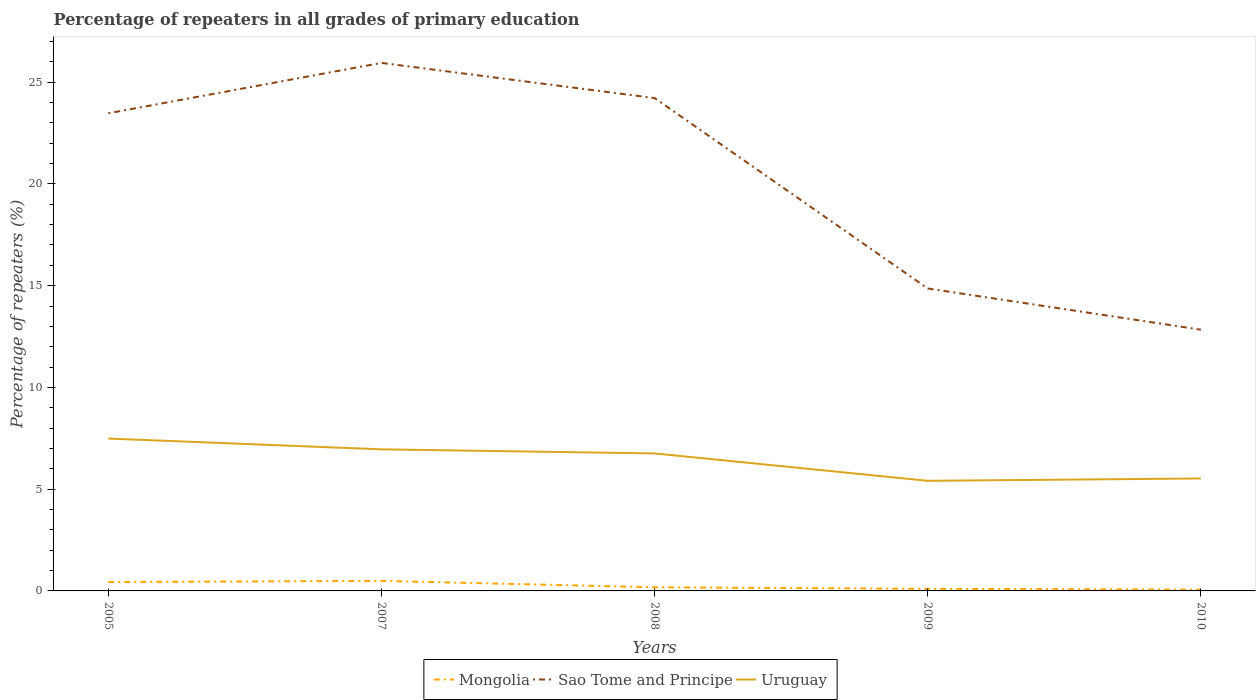Is the number of lines equal to the number of legend labels?
Your response must be concise. Yes. Across all years, what is the maximum percentage of repeaters in Mongolia?
Your answer should be compact. 0.06. In which year was the percentage of repeaters in Mongolia maximum?
Give a very brief answer. 2010. What is the total percentage of repeaters in Uruguay in the graph?
Make the answer very short. 1.55. What is the difference between the highest and the second highest percentage of repeaters in Uruguay?
Make the answer very short. 2.08. What is the difference between the highest and the lowest percentage of repeaters in Uruguay?
Your answer should be compact. 3. Is the percentage of repeaters in Mongolia strictly greater than the percentage of repeaters in Sao Tome and Principe over the years?
Keep it short and to the point. Yes. How many lines are there?
Ensure brevity in your answer.  3. What is the difference between two consecutive major ticks on the Y-axis?
Give a very brief answer. 5. Are the values on the major ticks of Y-axis written in scientific E-notation?
Your answer should be compact. No. Does the graph contain any zero values?
Give a very brief answer. No. How many legend labels are there?
Make the answer very short. 3. How are the legend labels stacked?
Ensure brevity in your answer.  Horizontal. What is the title of the graph?
Ensure brevity in your answer.  Percentage of repeaters in all grades of primary education. Does "Equatorial Guinea" appear as one of the legend labels in the graph?
Provide a short and direct response. No. What is the label or title of the X-axis?
Offer a very short reply. Years. What is the label or title of the Y-axis?
Your answer should be very brief. Percentage of repeaters (%). What is the Percentage of repeaters (%) of Mongolia in 2005?
Keep it short and to the point. 0.44. What is the Percentage of repeaters (%) in Sao Tome and Principe in 2005?
Provide a succinct answer. 23.47. What is the Percentage of repeaters (%) of Uruguay in 2005?
Your answer should be very brief. 7.49. What is the Percentage of repeaters (%) in Mongolia in 2007?
Your response must be concise. 0.49. What is the Percentage of repeaters (%) in Sao Tome and Principe in 2007?
Your answer should be compact. 25.95. What is the Percentage of repeaters (%) in Uruguay in 2007?
Make the answer very short. 6.96. What is the Percentage of repeaters (%) in Mongolia in 2008?
Offer a very short reply. 0.18. What is the Percentage of repeaters (%) of Sao Tome and Principe in 2008?
Keep it short and to the point. 24.22. What is the Percentage of repeaters (%) of Uruguay in 2008?
Offer a very short reply. 6.76. What is the Percentage of repeaters (%) of Mongolia in 2009?
Your response must be concise. 0.1. What is the Percentage of repeaters (%) of Sao Tome and Principe in 2009?
Ensure brevity in your answer.  14.86. What is the Percentage of repeaters (%) in Uruguay in 2009?
Provide a short and direct response. 5.41. What is the Percentage of repeaters (%) in Mongolia in 2010?
Provide a succinct answer. 0.06. What is the Percentage of repeaters (%) in Sao Tome and Principe in 2010?
Your answer should be compact. 12.84. What is the Percentage of repeaters (%) in Uruguay in 2010?
Provide a short and direct response. 5.53. Across all years, what is the maximum Percentage of repeaters (%) of Mongolia?
Make the answer very short. 0.49. Across all years, what is the maximum Percentage of repeaters (%) of Sao Tome and Principe?
Keep it short and to the point. 25.95. Across all years, what is the maximum Percentage of repeaters (%) of Uruguay?
Ensure brevity in your answer.  7.49. Across all years, what is the minimum Percentage of repeaters (%) of Mongolia?
Make the answer very short. 0.06. Across all years, what is the minimum Percentage of repeaters (%) of Sao Tome and Principe?
Offer a terse response. 12.84. Across all years, what is the minimum Percentage of repeaters (%) in Uruguay?
Your answer should be very brief. 5.41. What is the total Percentage of repeaters (%) in Mongolia in the graph?
Give a very brief answer. 1.28. What is the total Percentage of repeaters (%) in Sao Tome and Principe in the graph?
Offer a terse response. 101.34. What is the total Percentage of repeaters (%) of Uruguay in the graph?
Your answer should be compact. 32.14. What is the difference between the Percentage of repeaters (%) of Mongolia in 2005 and that in 2007?
Give a very brief answer. -0.06. What is the difference between the Percentage of repeaters (%) of Sao Tome and Principe in 2005 and that in 2007?
Your answer should be very brief. -2.47. What is the difference between the Percentage of repeaters (%) in Uruguay in 2005 and that in 2007?
Provide a short and direct response. 0.53. What is the difference between the Percentage of repeaters (%) in Mongolia in 2005 and that in 2008?
Your answer should be compact. 0.26. What is the difference between the Percentage of repeaters (%) in Sao Tome and Principe in 2005 and that in 2008?
Provide a succinct answer. -0.75. What is the difference between the Percentage of repeaters (%) of Uruguay in 2005 and that in 2008?
Your answer should be compact. 0.73. What is the difference between the Percentage of repeaters (%) in Mongolia in 2005 and that in 2009?
Make the answer very short. 0.33. What is the difference between the Percentage of repeaters (%) in Sao Tome and Principe in 2005 and that in 2009?
Make the answer very short. 8.61. What is the difference between the Percentage of repeaters (%) of Uruguay in 2005 and that in 2009?
Offer a terse response. 2.08. What is the difference between the Percentage of repeaters (%) in Mongolia in 2005 and that in 2010?
Provide a short and direct response. 0.37. What is the difference between the Percentage of repeaters (%) of Sao Tome and Principe in 2005 and that in 2010?
Give a very brief answer. 10.64. What is the difference between the Percentage of repeaters (%) in Uruguay in 2005 and that in 2010?
Provide a short and direct response. 1.96. What is the difference between the Percentage of repeaters (%) in Mongolia in 2007 and that in 2008?
Provide a succinct answer. 0.31. What is the difference between the Percentage of repeaters (%) of Sao Tome and Principe in 2007 and that in 2008?
Your answer should be very brief. 1.73. What is the difference between the Percentage of repeaters (%) in Uruguay in 2007 and that in 2008?
Your answer should be compact. 0.2. What is the difference between the Percentage of repeaters (%) of Mongolia in 2007 and that in 2009?
Your response must be concise. 0.39. What is the difference between the Percentage of repeaters (%) in Sao Tome and Principe in 2007 and that in 2009?
Your answer should be compact. 11.09. What is the difference between the Percentage of repeaters (%) in Uruguay in 2007 and that in 2009?
Give a very brief answer. 1.55. What is the difference between the Percentage of repeaters (%) of Mongolia in 2007 and that in 2010?
Your answer should be very brief. 0.43. What is the difference between the Percentage of repeaters (%) in Sao Tome and Principe in 2007 and that in 2010?
Your response must be concise. 13.11. What is the difference between the Percentage of repeaters (%) in Uruguay in 2007 and that in 2010?
Your answer should be very brief. 1.43. What is the difference between the Percentage of repeaters (%) of Mongolia in 2008 and that in 2009?
Your answer should be compact. 0.08. What is the difference between the Percentage of repeaters (%) of Sao Tome and Principe in 2008 and that in 2009?
Offer a very short reply. 9.36. What is the difference between the Percentage of repeaters (%) in Uruguay in 2008 and that in 2009?
Offer a terse response. 1.35. What is the difference between the Percentage of repeaters (%) of Mongolia in 2008 and that in 2010?
Offer a very short reply. 0.12. What is the difference between the Percentage of repeaters (%) of Sao Tome and Principe in 2008 and that in 2010?
Give a very brief answer. 11.38. What is the difference between the Percentage of repeaters (%) in Uruguay in 2008 and that in 2010?
Keep it short and to the point. 1.23. What is the difference between the Percentage of repeaters (%) in Mongolia in 2009 and that in 2010?
Give a very brief answer. 0.04. What is the difference between the Percentage of repeaters (%) in Sao Tome and Principe in 2009 and that in 2010?
Your response must be concise. 2.02. What is the difference between the Percentage of repeaters (%) in Uruguay in 2009 and that in 2010?
Your answer should be very brief. -0.12. What is the difference between the Percentage of repeaters (%) of Mongolia in 2005 and the Percentage of repeaters (%) of Sao Tome and Principe in 2007?
Provide a short and direct response. -25.51. What is the difference between the Percentage of repeaters (%) in Mongolia in 2005 and the Percentage of repeaters (%) in Uruguay in 2007?
Offer a terse response. -6.52. What is the difference between the Percentage of repeaters (%) of Sao Tome and Principe in 2005 and the Percentage of repeaters (%) of Uruguay in 2007?
Keep it short and to the point. 16.52. What is the difference between the Percentage of repeaters (%) of Mongolia in 2005 and the Percentage of repeaters (%) of Sao Tome and Principe in 2008?
Offer a terse response. -23.78. What is the difference between the Percentage of repeaters (%) of Mongolia in 2005 and the Percentage of repeaters (%) of Uruguay in 2008?
Provide a short and direct response. -6.32. What is the difference between the Percentage of repeaters (%) in Sao Tome and Principe in 2005 and the Percentage of repeaters (%) in Uruguay in 2008?
Your answer should be very brief. 16.72. What is the difference between the Percentage of repeaters (%) of Mongolia in 2005 and the Percentage of repeaters (%) of Sao Tome and Principe in 2009?
Keep it short and to the point. -14.43. What is the difference between the Percentage of repeaters (%) of Mongolia in 2005 and the Percentage of repeaters (%) of Uruguay in 2009?
Offer a very short reply. -4.98. What is the difference between the Percentage of repeaters (%) in Sao Tome and Principe in 2005 and the Percentage of repeaters (%) in Uruguay in 2009?
Provide a succinct answer. 18.06. What is the difference between the Percentage of repeaters (%) in Mongolia in 2005 and the Percentage of repeaters (%) in Sao Tome and Principe in 2010?
Provide a short and direct response. -12.4. What is the difference between the Percentage of repeaters (%) of Mongolia in 2005 and the Percentage of repeaters (%) of Uruguay in 2010?
Provide a short and direct response. -5.09. What is the difference between the Percentage of repeaters (%) of Sao Tome and Principe in 2005 and the Percentage of repeaters (%) of Uruguay in 2010?
Provide a succinct answer. 17.95. What is the difference between the Percentage of repeaters (%) of Mongolia in 2007 and the Percentage of repeaters (%) of Sao Tome and Principe in 2008?
Offer a very short reply. -23.73. What is the difference between the Percentage of repeaters (%) of Mongolia in 2007 and the Percentage of repeaters (%) of Uruguay in 2008?
Offer a very short reply. -6.26. What is the difference between the Percentage of repeaters (%) of Sao Tome and Principe in 2007 and the Percentage of repeaters (%) of Uruguay in 2008?
Your response must be concise. 19.19. What is the difference between the Percentage of repeaters (%) of Mongolia in 2007 and the Percentage of repeaters (%) of Sao Tome and Principe in 2009?
Your answer should be compact. -14.37. What is the difference between the Percentage of repeaters (%) in Mongolia in 2007 and the Percentage of repeaters (%) in Uruguay in 2009?
Provide a succinct answer. -4.92. What is the difference between the Percentage of repeaters (%) of Sao Tome and Principe in 2007 and the Percentage of repeaters (%) of Uruguay in 2009?
Provide a succinct answer. 20.54. What is the difference between the Percentage of repeaters (%) of Mongolia in 2007 and the Percentage of repeaters (%) of Sao Tome and Principe in 2010?
Offer a very short reply. -12.34. What is the difference between the Percentage of repeaters (%) in Mongolia in 2007 and the Percentage of repeaters (%) in Uruguay in 2010?
Ensure brevity in your answer.  -5.03. What is the difference between the Percentage of repeaters (%) of Sao Tome and Principe in 2007 and the Percentage of repeaters (%) of Uruguay in 2010?
Make the answer very short. 20.42. What is the difference between the Percentage of repeaters (%) of Mongolia in 2008 and the Percentage of repeaters (%) of Sao Tome and Principe in 2009?
Provide a succinct answer. -14.68. What is the difference between the Percentage of repeaters (%) in Mongolia in 2008 and the Percentage of repeaters (%) in Uruguay in 2009?
Offer a terse response. -5.23. What is the difference between the Percentage of repeaters (%) of Sao Tome and Principe in 2008 and the Percentage of repeaters (%) of Uruguay in 2009?
Ensure brevity in your answer.  18.81. What is the difference between the Percentage of repeaters (%) of Mongolia in 2008 and the Percentage of repeaters (%) of Sao Tome and Principe in 2010?
Provide a short and direct response. -12.66. What is the difference between the Percentage of repeaters (%) in Mongolia in 2008 and the Percentage of repeaters (%) in Uruguay in 2010?
Make the answer very short. -5.35. What is the difference between the Percentage of repeaters (%) of Sao Tome and Principe in 2008 and the Percentage of repeaters (%) of Uruguay in 2010?
Give a very brief answer. 18.69. What is the difference between the Percentage of repeaters (%) of Mongolia in 2009 and the Percentage of repeaters (%) of Sao Tome and Principe in 2010?
Ensure brevity in your answer.  -12.74. What is the difference between the Percentage of repeaters (%) in Mongolia in 2009 and the Percentage of repeaters (%) in Uruguay in 2010?
Your answer should be compact. -5.43. What is the difference between the Percentage of repeaters (%) of Sao Tome and Principe in 2009 and the Percentage of repeaters (%) of Uruguay in 2010?
Make the answer very short. 9.34. What is the average Percentage of repeaters (%) in Mongolia per year?
Offer a terse response. 0.26. What is the average Percentage of repeaters (%) of Sao Tome and Principe per year?
Give a very brief answer. 20.27. What is the average Percentage of repeaters (%) of Uruguay per year?
Give a very brief answer. 6.43. In the year 2005, what is the difference between the Percentage of repeaters (%) in Mongolia and Percentage of repeaters (%) in Sao Tome and Principe?
Give a very brief answer. -23.04. In the year 2005, what is the difference between the Percentage of repeaters (%) in Mongolia and Percentage of repeaters (%) in Uruguay?
Provide a short and direct response. -7.05. In the year 2005, what is the difference between the Percentage of repeaters (%) of Sao Tome and Principe and Percentage of repeaters (%) of Uruguay?
Ensure brevity in your answer.  15.99. In the year 2007, what is the difference between the Percentage of repeaters (%) of Mongolia and Percentage of repeaters (%) of Sao Tome and Principe?
Offer a very short reply. -25.45. In the year 2007, what is the difference between the Percentage of repeaters (%) in Mongolia and Percentage of repeaters (%) in Uruguay?
Offer a very short reply. -6.46. In the year 2007, what is the difference between the Percentage of repeaters (%) in Sao Tome and Principe and Percentage of repeaters (%) in Uruguay?
Offer a terse response. 18.99. In the year 2008, what is the difference between the Percentage of repeaters (%) in Mongolia and Percentage of repeaters (%) in Sao Tome and Principe?
Offer a terse response. -24.04. In the year 2008, what is the difference between the Percentage of repeaters (%) of Mongolia and Percentage of repeaters (%) of Uruguay?
Offer a very short reply. -6.58. In the year 2008, what is the difference between the Percentage of repeaters (%) of Sao Tome and Principe and Percentage of repeaters (%) of Uruguay?
Give a very brief answer. 17.46. In the year 2009, what is the difference between the Percentage of repeaters (%) of Mongolia and Percentage of repeaters (%) of Sao Tome and Principe?
Offer a terse response. -14.76. In the year 2009, what is the difference between the Percentage of repeaters (%) in Mongolia and Percentage of repeaters (%) in Uruguay?
Provide a succinct answer. -5.31. In the year 2009, what is the difference between the Percentage of repeaters (%) of Sao Tome and Principe and Percentage of repeaters (%) of Uruguay?
Your response must be concise. 9.45. In the year 2010, what is the difference between the Percentage of repeaters (%) of Mongolia and Percentage of repeaters (%) of Sao Tome and Principe?
Keep it short and to the point. -12.77. In the year 2010, what is the difference between the Percentage of repeaters (%) in Mongolia and Percentage of repeaters (%) in Uruguay?
Offer a very short reply. -5.46. In the year 2010, what is the difference between the Percentage of repeaters (%) in Sao Tome and Principe and Percentage of repeaters (%) in Uruguay?
Your answer should be compact. 7.31. What is the ratio of the Percentage of repeaters (%) of Mongolia in 2005 to that in 2007?
Your answer should be very brief. 0.88. What is the ratio of the Percentage of repeaters (%) of Sao Tome and Principe in 2005 to that in 2007?
Ensure brevity in your answer.  0.9. What is the ratio of the Percentage of repeaters (%) of Uruguay in 2005 to that in 2007?
Keep it short and to the point. 1.08. What is the ratio of the Percentage of repeaters (%) in Mongolia in 2005 to that in 2008?
Your answer should be compact. 2.43. What is the ratio of the Percentage of repeaters (%) in Sao Tome and Principe in 2005 to that in 2008?
Provide a succinct answer. 0.97. What is the ratio of the Percentage of repeaters (%) of Uruguay in 2005 to that in 2008?
Keep it short and to the point. 1.11. What is the ratio of the Percentage of repeaters (%) in Mongolia in 2005 to that in 2009?
Your answer should be very brief. 4.27. What is the ratio of the Percentage of repeaters (%) in Sao Tome and Principe in 2005 to that in 2009?
Make the answer very short. 1.58. What is the ratio of the Percentage of repeaters (%) in Uruguay in 2005 to that in 2009?
Your answer should be compact. 1.38. What is the ratio of the Percentage of repeaters (%) of Mongolia in 2005 to that in 2010?
Your answer should be compact. 6.79. What is the ratio of the Percentage of repeaters (%) of Sao Tome and Principe in 2005 to that in 2010?
Keep it short and to the point. 1.83. What is the ratio of the Percentage of repeaters (%) of Uruguay in 2005 to that in 2010?
Offer a very short reply. 1.35. What is the ratio of the Percentage of repeaters (%) in Mongolia in 2007 to that in 2008?
Your answer should be very brief. 2.75. What is the ratio of the Percentage of repeaters (%) of Sao Tome and Principe in 2007 to that in 2008?
Offer a very short reply. 1.07. What is the ratio of the Percentage of repeaters (%) of Uruguay in 2007 to that in 2008?
Provide a succinct answer. 1.03. What is the ratio of the Percentage of repeaters (%) in Mongolia in 2007 to that in 2009?
Ensure brevity in your answer.  4.84. What is the ratio of the Percentage of repeaters (%) of Sao Tome and Principe in 2007 to that in 2009?
Provide a short and direct response. 1.75. What is the ratio of the Percentage of repeaters (%) in Uruguay in 2007 to that in 2009?
Keep it short and to the point. 1.29. What is the ratio of the Percentage of repeaters (%) of Mongolia in 2007 to that in 2010?
Ensure brevity in your answer.  7.69. What is the ratio of the Percentage of repeaters (%) in Sao Tome and Principe in 2007 to that in 2010?
Offer a very short reply. 2.02. What is the ratio of the Percentage of repeaters (%) in Uruguay in 2007 to that in 2010?
Keep it short and to the point. 1.26. What is the ratio of the Percentage of repeaters (%) in Mongolia in 2008 to that in 2009?
Offer a terse response. 1.76. What is the ratio of the Percentage of repeaters (%) of Sao Tome and Principe in 2008 to that in 2009?
Your answer should be very brief. 1.63. What is the ratio of the Percentage of repeaters (%) in Uruguay in 2008 to that in 2009?
Make the answer very short. 1.25. What is the ratio of the Percentage of repeaters (%) of Mongolia in 2008 to that in 2010?
Your answer should be compact. 2.79. What is the ratio of the Percentage of repeaters (%) of Sao Tome and Principe in 2008 to that in 2010?
Give a very brief answer. 1.89. What is the ratio of the Percentage of repeaters (%) in Uruguay in 2008 to that in 2010?
Your answer should be compact. 1.22. What is the ratio of the Percentage of repeaters (%) of Mongolia in 2009 to that in 2010?
Offer a very short reply. 1.59. What is the ratio of the Percentage of repeaters (%) in Sao Tome and Principe in 2009 to that in 2010?
Your response must be concise. 1.16. What is the ratio of the Percentage of repeaters (%) in Uruguay in 2009 to that in 2010?
Make the answer very short. 0.98. What is the difference between the highest and the second highest Percentage of repeaters (%) of Mongolia?
Your response must be concise. 0.06. What is the difference between the highest and the second highest Percentage of repeaters (%) in Sao Tome and Principe?
Ensure brevity in your answer.  1.73. What is the difference between the highest and the second highest Percentage of repeaters (%) in Uruguay?
Give a very brief answer. 0.53. What is the difference between the highest and the lowest Percentage of repeaters (%) of Mongolia?
Provide a succinct answer. 0.43. What is the difference between the highest and the lowest Percentage of repeaters (%) in Sao Tome and Principe?
Give a very brief answer. 13.11. What is the difference between the highest and the lowest Percentage of repeaters (%) of Uruguay?
Keep it short and to the point. 2.08. 